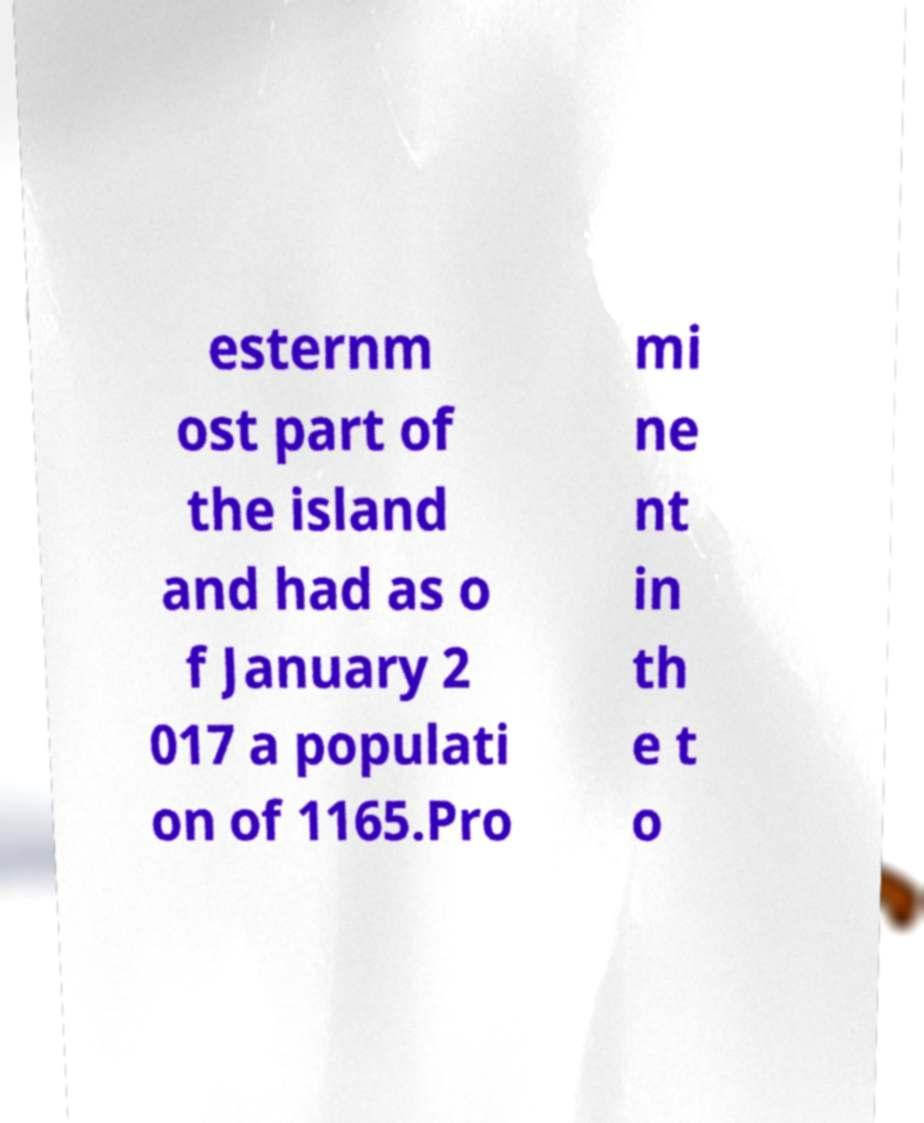Please read and relay the text visible in this image. What does it say? esternm ost part of the island and had as o f January 2 017 a populati on of 1165.Pro mi ne nt in th e t o 